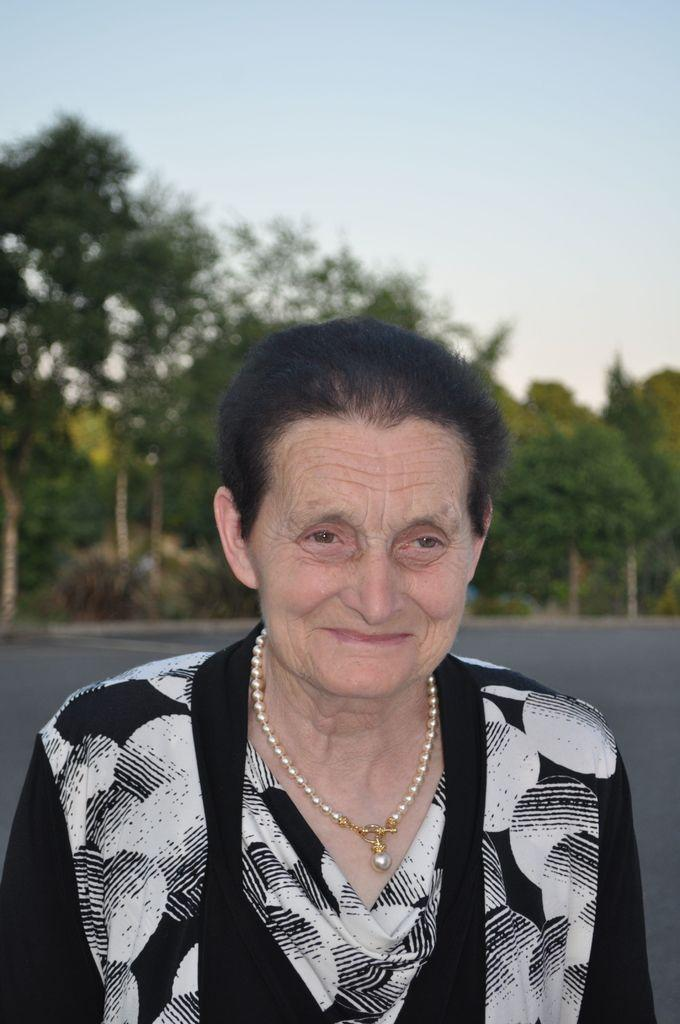Who is the main subject in the image? There is a woman in the image. What is the woman doing in the image? The woman is smiling. What can be seen in the background of the image? There is a road, trees, and the sky visible in the background of the image. What type of sound can be heard coming from the woman's daughter in the image? There is no mention of a daughter in the image, so it is not possible to determine what sound might be heard. 